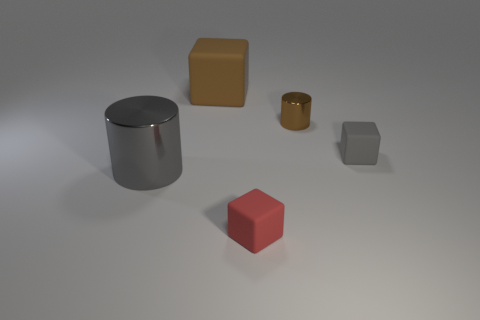Can you describe the shapes and colors of the objects in the image? Certainly! In the image, there are four distinct objects: a gray metal cylinder, a red cube, a yellow cube, and a smaller brown cylinder. The gray cylinder has a smooth, reflective surface, indicative of a metallic material. The red cube, on the other hand, has a matte finish with distinct edges and corners. The yellow cube has similar properties to the red cube but in a different color, and the smaller brown cylinder has a surface that reflects light differently, suggesting a non-metallic material. 